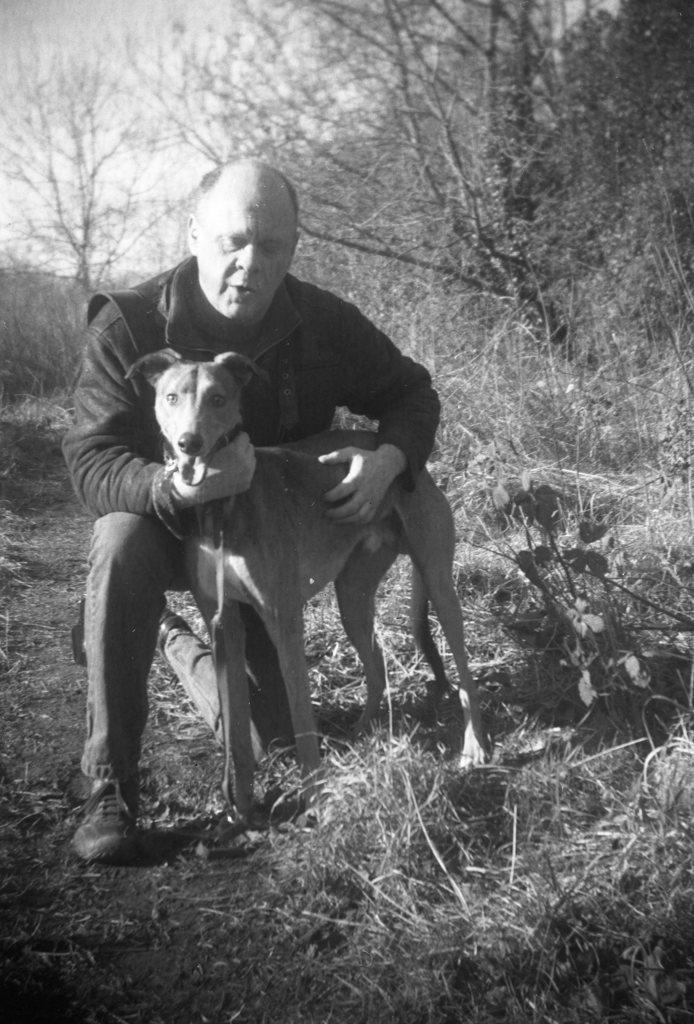How would you summarize this image in a sentence or two? This picture is taken outside which is in black and white. A person is in squatting position and holding a dog. He is wearing jacket, trousers and boots. Towards the right there are group of plants and trees. 